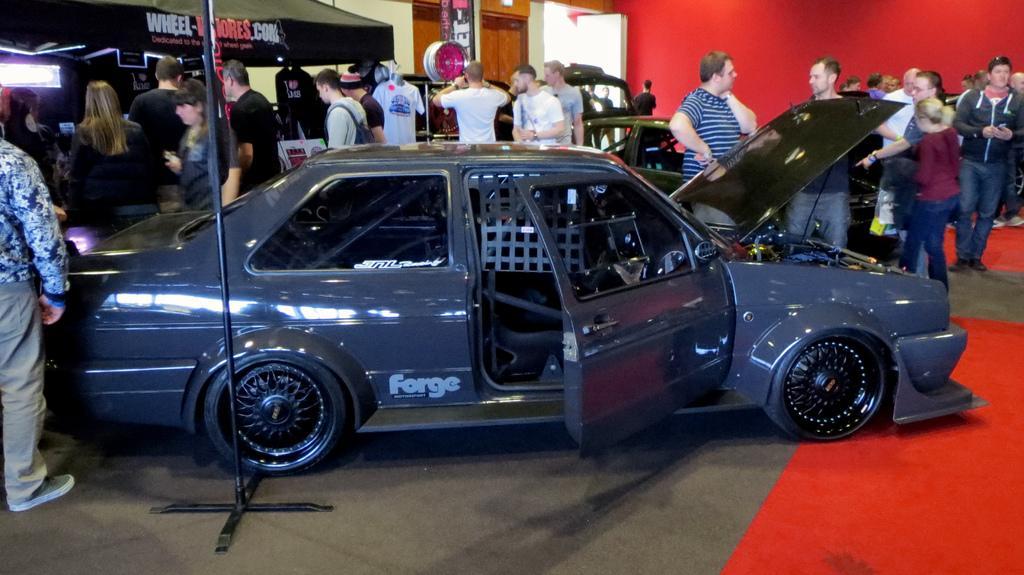How would you summarize this image in a sentence or two? In this picture, we can see a car parked on the floor and in front of the car there is a pole and behind the car there are groups of people standing, cars and a stall and at the background there is a red wall and a banner. 